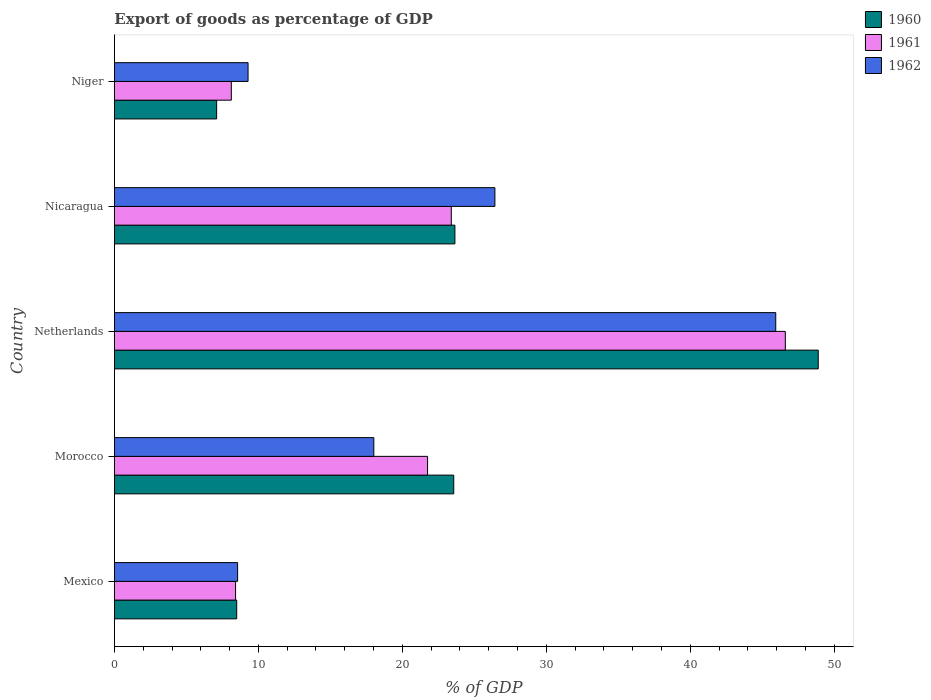Are the number of bars per tick equal to the number of legend labels?
Keep it short and to the point. Yes. How many bars are there on the 3rd tick from the top?
Give a very brief answer. 3. What is the label of the 2nd group of bars from the top?
Your answer should be very brief. Nicaragua. In how many cases, is the number of bars for a given country not equal to the number of legend labels?
Ensure brevity in your answer.  0. What is the export of goods as percentage of GDP in 1961 in Mexico?
Your answer should be very brief. 8.42. Across all countries, what is the maximum export of goods as percentage of GDP in 1961?
Ensure brevity in your answer.  46.61. Across all countries, what is the minimum export of goods as percentage of GDP in 1962?
Offer a terse response. 8.56. In which country was the export of goods as percentage of GDP in 1961 maximum?
Offer a terse response. Netherlands. In which country was the export of goods as percentage of GDP in 1960 minimum?
Your answer should be compact. Niger. What is the total export of goods as percentage of GDP in 1960 in the graph?
Provide a short and direct response. 111.71. What is the difference between the export of goods as percentage of GDP in 1961 in Morocco and that in Netherlands?
Ensure brevity in your answer.  -24.85. What is the difference between the export of goods as percentage of GDP in 1962 in Netherlands and the export of goods as percentage of GDP in 1960 in Mexico?
Your answer should be compact. 37.45. What is the average export of goods as percentage of GDP in 1960 per country?
Give a very brief answer. 22.34. What is the difference between the export of goods as percentage of GDP in 1962 and export of goods as percentage of GDP in 1960 in Niger?
Make the answer very short. 2.18. What is the ratio of the export of goods as percentage of GDP in 1960 in Morocco to that in Niger?
Offer a terse response. 3.32. Is the difference between the export of goods as percentage of GDP in 1962 in Netherlands and Nicaragua greater than the difference between the export of goods as percentage of GDP in 1960 in Netherlands and Nicaragua?
Your answer should be compact. No. What is the difference between the highest and the second highest export of goods as percentage of GDP in 1961?
Ensure brevity in your answer.  23.21. What is the difference between the highest and the lowest export of goods as percentage of GDP in 1961?
Provide a succinct answer. 38.49. In how many countries, is the export of goods as percentage of GDP in 1960 greater than the average export of goods as percentage of GDP in 1960 taken over all countries?
Provide a succinct answer. 3. What does the 1st bar from the bottom in Netherlands represents?
Give a very brief answer. 1960. Is it the case that in every country, the sum of the export of goods as percentage of GDP in 1960 and export of goods as percentage of GDP in 1961 is greater than the export of goods as percentage of GDP in 1962?
Provide a succinct answer. Yes. How many bars are there?
Make the answer very short. 15. Are all the bars in the graph horizontal?
Offer a very short reply. Yes. What is the difference between two consecutive major ticks on the X-axis?
Provide a succinct answer. 10. Are the values on the major ticks of X-axis written in scientific E-notation?
Make the answer very short. No. Does the graph contain any zero values?
Ensure brevity in your answer.  No. Where does the legend appear in the graph?
Provide a succinct answer. Top right. How many legend labels are there?
Keep it short and to the point. 3. What is the title of the graph?
Give a very brief answer. Export of goods as percentage of GDP. What is the label or title of the X-axis?
Your answer should be compact. % of GDP. What is the % of GDP in 1960 in Mexico?
Provide a short and direct response. 8.49. What is the % of GDP of 1961 in Mexico?
Offer a terse response. 8.42. What is the % of GDP in 1962 in Mexico?
Keep it short and to the point. 8.56. What is the % of GDP of 1960 in Morocco?
Keep it short and to the point. 23.57. What is the % of GDP in 1961 in Morocco?
Make the answer very short. 21.75. What is the % of GDP of 1962 in Morocco?
Give a very brief answer. 18.02. What is the % of GDP of 1960 in Netherlands?
Your answer should be very brief. 48.89. What is the % of GDP in 1961 in Netherlands?
Ensure brevity in your answer.  46.61. What is the % of GDP of 1962 in Netherlands?
Ensure brevity in your answer.  45.94. What is the % of GDP of 1960 in Nicaragua?
Keep it short and to the point. 23.65. What is the % of GDP of 1961 in Nicaragua?
Your answer should be compact. 23.4. What is the % of GDP in 1962 in Nicaragua?
Provide a succinct answer. 26.43. What is the % of GDP of 1960 in Niger?
Offer a terse response. 7.1. What is the % of GDP in 1961 in Niger?
Your answer should be compact. 8.12. What is the % of GDP of 1962 in Niger?
Your response must be concise. 9.28. Across all countries, what is the maximum % of GDP in 1960?
Provide a short and direct response. 48.89. Across all countries, what is the maximum % of GDP in 1961?
Your answer should be compact. 46.61. Across all countries, what is the maximum % of GDP in 1962?
Your response must be concise. 45.94. Across all countries, what is the minimum % of GDP of 1960?
Ensure brevity in your answer.  7.1. Across all countries, what is the minimum % of GDP in 1961?
Offer a terse response. 8.12. Across all countries, what is the minimum % of GDP in 1962?
Your answer should be compact. 8.56. What is the total % of GDP in 1960 in the graph?
Give a very brief answer. 111.71. What is the total % of GDP of 1961 in the graph?
Make the answer very short. 108.3. What is the total % of GDP of 1962 in the graph?
Make the answer very short. 108.24. What is the difference between the % of GDP of 1960 in Mexico and that in Morocco?
Ensure brevity in your answer.  -15.08. What is the difference between the % of GDP of 1961 in Mexico and that in Morocco?
Provide a short and direct response. -13.34. What is the difference between the % of GDP in 1962 in Mexico and that in Morocco?
Your answer should be compact. -9.46. What is the difference between the % of GDP of 1960 in Mexico and that in Netherlands?
Make the answer very short. -40.4. What is the difference between the % of GDP of 1961 in Mexico and that in Netherlands?
Your answer should be compact. -38.19. What is the difference between the % of GDP of 1962 in Mexico and that in Netherlands?
Keep it short and to the point. -37.39. What is the difference between the % of GDP in 1960 in Mexico and that in Nicaragua?
Your answer should be compact. -15.16. What is the difference between the % of GDP of 1961 in Mexico and that in Nicaragua?
Your response must be concise. -14.99. What is the difference between the % of GDP of 1962 in Mexico and that in Nicaragua?
Your response must be concise. -17.87. What is the difference between the % of GDP in 1960 in Mexico and that in Niger?
Your answer should be compact. 1.39. What is the difference between the % of GDP of 1961 in Mexico and that in Niger?
Keep it short and to the point. 0.29. What is the difference between the % of GDP in 1962 in Mexico and that in Niger?
Ensure brevity in your answer.  -0.73. What is the difference between the % of GDP in 1960 in Morocco and that in Netherlands?
Provide a succinct answer. -25.32. What is the difference between the % of GDP in 1961 in Morocco and that in Netherlands?
Give a very brief answer. -24.85. What is the difference between the % of GDP of 1962 in Morocco and that in Netherlands?
Make the answer very short. -27.92. What is the difference between the % of GDP of 1960 in Morocco and that in Nicaragua?
Ensure brevity in your answer.  -0.08. What is the difference between the % of GDP of 1961 in Morocco and that in Nicaragua?
Make the answer very short. -1.65. What is the difference between the % of GDP of 1962 in Morocco and that in Nicaragua?
Your answer should be very brief. -8.41. What is the difference between the % of GDP in 1960 in Morocco and that in Niger?
Keep it short and to the point. 16.47. What is the difference between the % of GDP in 1961 in Morocco and that in Niger?
Provide a short and direct response. 13.63. What is the difference between the % of GDP in 1962 in Morocco and that in Niger?
Keep it short and to the point. 8.74. What is the difference between the % of GDP of 1960 in Netherlands and that in Nicaragua?
Provide a succinct answer. 25.24. What is the difference between the % of GDP in 1961 in Netherlands and that in Nicaragua?
Ensure brevity in your answer.  23.21. What is the difference between the % of GDP of 1962 in Netherlands and that in Nicaragua?
Make the answer very short. 19.51. What is the difference between the % of GDP of 1960 in Netherlands and that in Niger?
Your answer should be very brief. 41.79. What is the difference between the % of GDP of 1961 in Netherlands and that in Niger?
Keep it short and to the point. 38.49. What is the difference between the % of GDP of 1962 in Netherlands and that in Niger?
Your answer should be compact. 36.66. What is the difference between the % of GDP of 1960 in Nicaragua and that in Niger?
Ensure brevity in your answer.  16.55. What is the difference between the % of GDP of 1961 in Nicaragua and that in Niger?
Keep it short and to the point. 15.28. What is the difference between the % of GDP of 1962 in Nicaragua and that in Niger?
Make the answer very short. 17.15. What is the difference between the % of GDP in 1960 in Mexico and the % of GDP in 1961 in Morocco?
Keep it short and to the point. -13.26. What is the difference between the % of GDP in 1960 in Mexico and the % of GDP in 1962 in Morocco?
Keep it short and to the point. -9.53. What is the difference between the % of GDP of 1961 in Mexico and the % of GDP of 1962 in Morocco?
Your response must be concise. -9.6. What is the difference between the % of GDP of 1960 in Mexico and the % of GDP of 1961 in Netherlands?
Offer a very short reply. -38.11. What is the difference between the % of GDP in 1960 in Mexico and the % of GDP in 1962 in Netherlands?
Your response must be concise. -37.45. What is the difference between the % of GDP in 1961 in Mexico and the % of GDP in 1962 in Netherlands?
Your answer should be very brief. -37.53. What is the difference between the % of GDP of 1960 in Mexico and the % of GDP of 1961 in Nicaragua?
Give a very brief answer. -14.91. What is the difference between the % of GDP of 1960 in Mexico and the % of GDP of 1962 in Nicaragua?
Give a very brief answer. -17.94. What is the difference between the % of GDP of 1961 in Mexico and the % of GDP of 1962 in Nicaragua?
Offer a terse response. -18.02. What is the difference between the % of GDP of 1960 in Mexico and the % of GDP of 1961 in Niger?
Provide a succinct answer. 0.37. What is the difference between the % of GDP in 1960 in Mexico and the % of GDP in 1962 in Niger?
Your answer should be very brief. -0.79. What is the difference between the % of GDP of 1961 in Mexico and the % of GDP of 1962 in Niger?
Your answer should be compact. -0.87. What is the difference between the % of GDP of 1960 in Morocco and the % of GDP of 1961 in Netherlands?
Provide a short and direct response. -23.04. What is the difference between the % of GDP in 1960 in Morocco and the % of GDP in 1962 in Netherlands?
Provide a succinct answer. -22.37. What is the difference between the % of GDP of 1961 in Morocco and the % of GDP of 1962 in Netherlands?
Provide a short and direct response. -24.19. What is the difference between the % of GDP of 1960 in Morocco and the % of GDP of 1961 in Nicaragua?
Ensure brevity in your answer.  0.17. What is the difference between the % of GDP of 1960 in Morocco and the % of GDP of 1962 in Nicaragua?
Offer a terse response. -2.86. What is the difference between the % of GDP in 1961 in Morocco and the % of GDP in 1962 in Nicaragua?
Your response must be concise. -4.68. What is the difference between the % of GDP of 1960 in Morocco and the % of GDP of 1961 in Niger?
Provide a succinct answer. 15.45. What is the difference between the % of GDP of 1960 in Morocco and the % of GDP of 1962 in Niger?
Make the answer very short. 14.29. What is the difference between the % of GDP of 1961 in Morocco and the % of GDP of 1962 in Niger?
Offer a terse response. 12.47. What is the difference between the % of GDP of 1960 in Netherlands and the % of GDP of 1961 in Nicaragua?
Keep it short and to the point. 25.49. What is the difference between the % of GDP in 1960 in Netherlands and the % of GDP in 1962 in Nicaragua?
Your answer should be compact. 22.46. What is the difference between the % of GDP of 1961 in Netherlands and the % of GDP of 1962 in Nicaragua?
Give a very brief answer. 20.18. What is the difference between the % of GDP in 1960 in Netherlands and the % of GDP in 1961 in Niger?
Your answer should be very brief. 40.77. What is the difference between the % of GDP of 1960 in Netherlands and the % of GDP of 1962 in Niger?
Offer a terse response. 39.61. What is the difference between the % of GDP in 1961 in Netherlands and the % of GDP in 1962 in Niger?
Your answer should be very brief. 37.32. What is the difference between the % of GDP of 1960 in Nicaragua and the % of GDP of 1961 in Niger?
Provide a succinct answer. 15.53. What is the difference between the % of GDP of 1960 in Nicaragua and the % of GDP of 1962 in Niger?
Make the answer very short. 14.37. What is the difference between the % of GDP in 1961 in Nicaragua and the % of GDP in 1962 in Niger?
Provide a short and direct response. 14.12. What is the average % of GDP in 1960 per country?
Your answer should be very brief. 22.34. What is the average % of GDP in 1961 per country?
Keep it short and to the point. 21.66. What is the average % of GDP of 1962 per country?
Your response must be concise. 21.65. What is the difference between the % of GDP of 1960 and % of GDP of 1961 in Mexico?
Provide a succinct answer. 0.08. What is the difference between the % of GDP in 1960 and % of GDP in 1962 in Mexico?
Your response must be concise. -0.06. What is the difference between the % of GDP in 1961 and % of GDP in 1962 in Mexico?
Provide a succinct answer. -0.14. What is the difference between the % of GDP in 1960 and % of GDP in 1961 in Morocco?
Offer a very short reply. 1.82. What is the difference between the % of GDP in 1960 and % of GDP in 1962 in Morocco?
Give a very brief answer. 5.55. What is the difference between the % of GDP in 1961 and % of GDP in 1962 in Morocco?
Make the answer very short. 3.73. What is the difference between the % of GDP in 1960 and % of GDP in 1961 in Netherlands?
Your answer should be compact. 2.29. What is the difference between the % of GDP of 1960 and % of GDP of 1962 in Netherlands?
Your response must be concise. 2.95. What is the difference between the % of GDP of 1961 and % of GDP of 1962 in Netherlands?
Offer a very short reply. 0.66. What is the difference between the % of GDP of 1960 and % of GDP of 1961 in Nicaragua?
Your answer should be compact. 0.25. What is the difference between the % of GDP in 1960 and % of GDP in 1962 in Nicaragua?
Keep it short and to the point. -2.78. What is the difference between the % of GDP in 1961 and % of GDP in 1962 in Nicaragua?
Offer a terse response. -3.03. What is the difference between the % of GDP of 1960 and % of GDP of 1961 in Niger?
Provide a succinct answer. -1.02. What is the difference between the % of GDP in 1960 and % of GDP in 1962 in Niger?
Give a very brief answer. -2.18. What is the difference between the % of GDP in 1961 and % of GDP in 1962 in Niger?
Your answer should be very brief. -1.16. What is the ratio of the % of GDP of 1960 in Mexico to that in Morocco?
Your answer should be very brief. 0.36. What is the ratio of the % of GDP in 1961 in Mexico to that in Morocco?
Offer a terse response. 0.39. What is the ratio of the % of GDP in 1962 in Mexico to that in Morocco?
Your answer should be compact. 0.47. What is the ratio of the % of GDP of 1960 in Mexico to that in Netherlands?
Provide a short and direct response. 0.17. What is the ratio of the % of GDP in 1961 in Mexico to that in Netherlands?
Keep it short and to the point. 0.18. What is the ratio of the % of GDP of 1962 in Mexico to that in Netherlands?
Offer a terse response. 0.19. What is the ratio of the % of GDP in 1960 in Mexico to that in Nicaragua?
Offer a very short reply. 0.36. What is the ratio of the % of GDP of 1961 in Mexico to that in Nicaragua?
Your answer should be compact. 0.36. What is the ratio of the % of GDP of 1962 in Mexico to that in Nicaragua?
Provide a succinct answer. 0.32. What is the ratio of the % of GDP of 1960 in Mexico to that in Niger?
Offer a very short reply. 1.2. What is the ratio of the % of GDP in 1961 in Mexico to that in Niger?
Ensure brevity in your answer.  1.04. What is the ratio of the % of GDP in 1962 in Mexico to that in Niger?
Make the answer very short. 0.92. What is the ratio of the % of GDP in 1960 in Morocco to that in Netherlands?
Offer a very short reply. 0.48. What is the ratio of the % of GDP of 1961 in Morocco to that in Netherlands?
Offer a terse response. 0.47. What is the ratio of the % of GDP in 1962 in Morocco to that in Netherlands?
Provide a succinct answer. 0.39. What is the ratio of the % of GDP in 1961 in Morocco to that in Nicaragua?
Provide a succinct answer. 0.93. What is the ratio of the % of GDP in 1962 in Morocco to that in Nicaragua?
Provide a succinct answer. 0.68. What is the ratio of the % of GDP of 1960 in Morocco to that in Niger?
Offer a terse response. 3.32. What is the ratio of the % of GDP in 1961 in Morocco to that in Niger?
Give a very brief answer. 2.68. What is the ratio of the % of GDP in 1962 in Morocco to that in Niger?
Offer a very short reply. 1.94. What is the ratio of the % of GDP of 1960 in Netherlands to that in Nicaragua?
Your answer should be very brief. 2.07. What is the ratio of the % of GDP in 1961 in Netherlands to that in Nicaragua?
Offer a terse response. 1.99. What is the ratio of the % of GDP of 1962 in Netherlands to that in Nicaragua?
Your answer should be very brief. 1.74. What is the ratio of the % of GDP in 1960 in Netherlands to that in Niger?
Ensure brevity in your answer.  6.89. What is the ratio of the % of GDP in 1961 in Netherlands to that in Niger?
Make the answer very short. 5.74. What is the ratio of the % of GDP of 1962 in Netherlands to that in Niger?
Provide a succinct answer. 4.95. What is the ratio of the % of GDP in 1960 in Nicaragua to that in Niger?
Your answer should be compact. 3.33. What is the ratio of the % of GDP of 1961 in Nicaragua to that in Niger?
Your answer should be very brief. 2.88. What is the ratio of the % of GDP in 1962 in Nicaragua to that in Niger?
Provide a short and direct response. 2.85. What is the difference between the highest and the second highest % of GDP in 1960?
Ensure brevity in your answer.  25.24. What is the difference between the highest and the second highest % of GDP in 1961?
Provide a succinct answer. 23.21. What is the difference between the highest and the second highest % of GDP of 1962?
Offer a very short reply. 19.51. What is the difference between the highest and the lowest % of GDP in 1960?
Make the answer very short. 41.79. What is the difference between the highest and the lowest % of GDP of 1961?
Give a very brief answer. 38.49. What is the difference between the highest and the lowest % of GDP of 1962?
Provide a succinct answer. 37.39. 